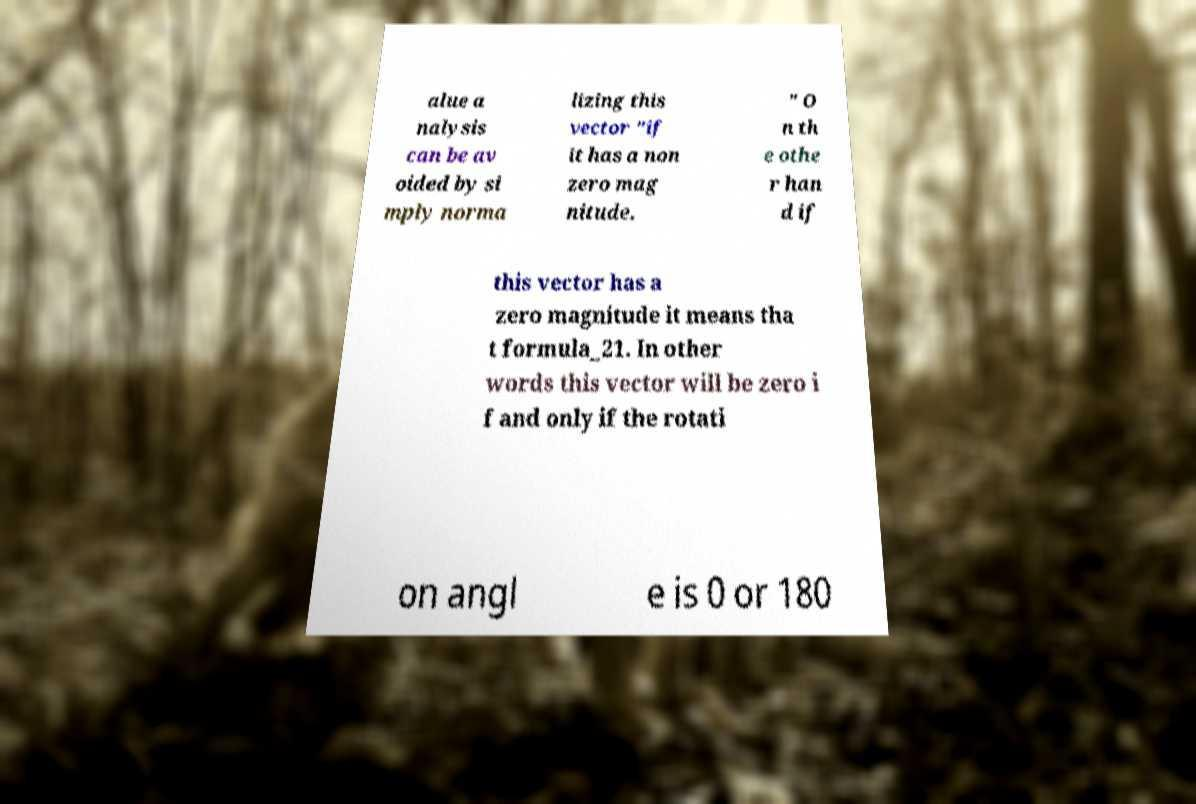Could you assist in decoding the text presented in this image and type it out clearly? alue a nalysis can be av oided by si mply norma lizing this vector "if it has a non zero mag nitude. " O n th e othe r han d if this vector has a zero magnitude it means tha t formula_21. In other words this vector will be zero i f and only if the rotati on angl e is 0 or 180 